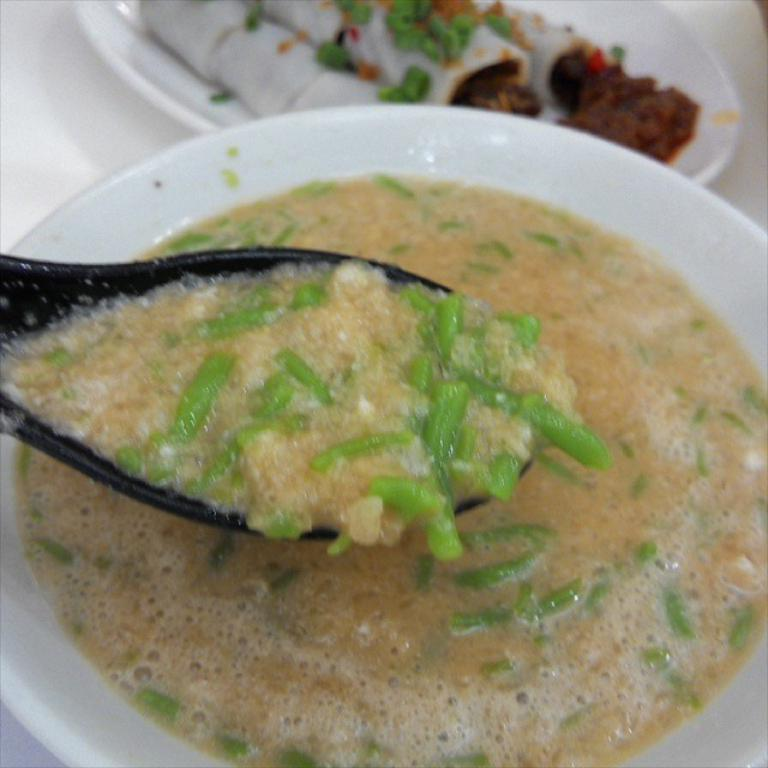What objects can be seen in the image related to eating? There are plates and a spoon with food items on it in the image. What surface are the plates and spoon placed on? The plates and spoon are placed on a white surface. What type of seed is growing on the spoon in the image? There is no seed growing on the spoon in the image; it has food items on it. What kind of creature can be seen interacting with the plates in the image? There is no creature present in the image; it only features plates and a spoon with food items. 